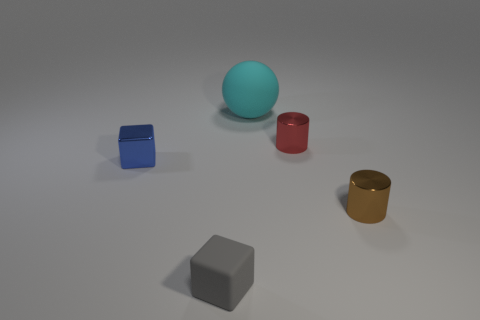Add 1 large objects. How many objects exist? 6 Subtract all cylinders. How many objects are left? 3 Add 5 red metallic objects. How many red metallic objects are left? 6 Add 1 large objects. How many large objects exist? 2 Subtract 0 green balls. How many objects are left? 5 Subtract all spheres. Subtract all large cyan blocks. How many objects are left? 4 